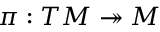<formula> <loc_0><loc_0><loc_500><loc_500>\pi \colon T M \twoheadrightarrow M</formula> 